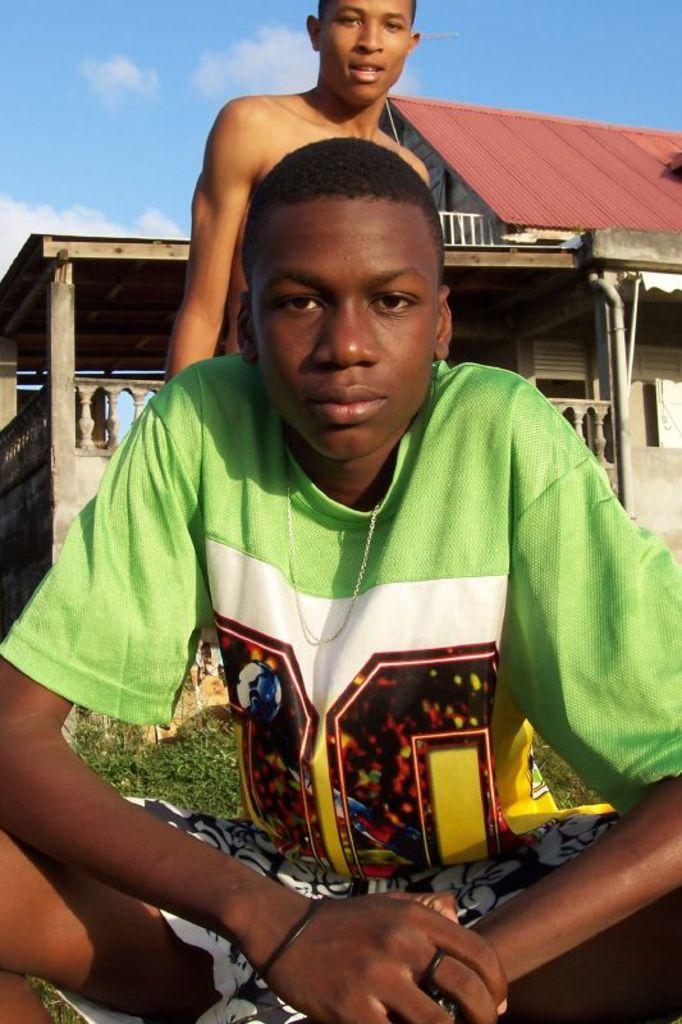Can you describe this image briefly? In this image I can see two persons. The person in front wearing green color shirt and black and white short. Background I can see a building in gray color and the sky is in blue and white color. 